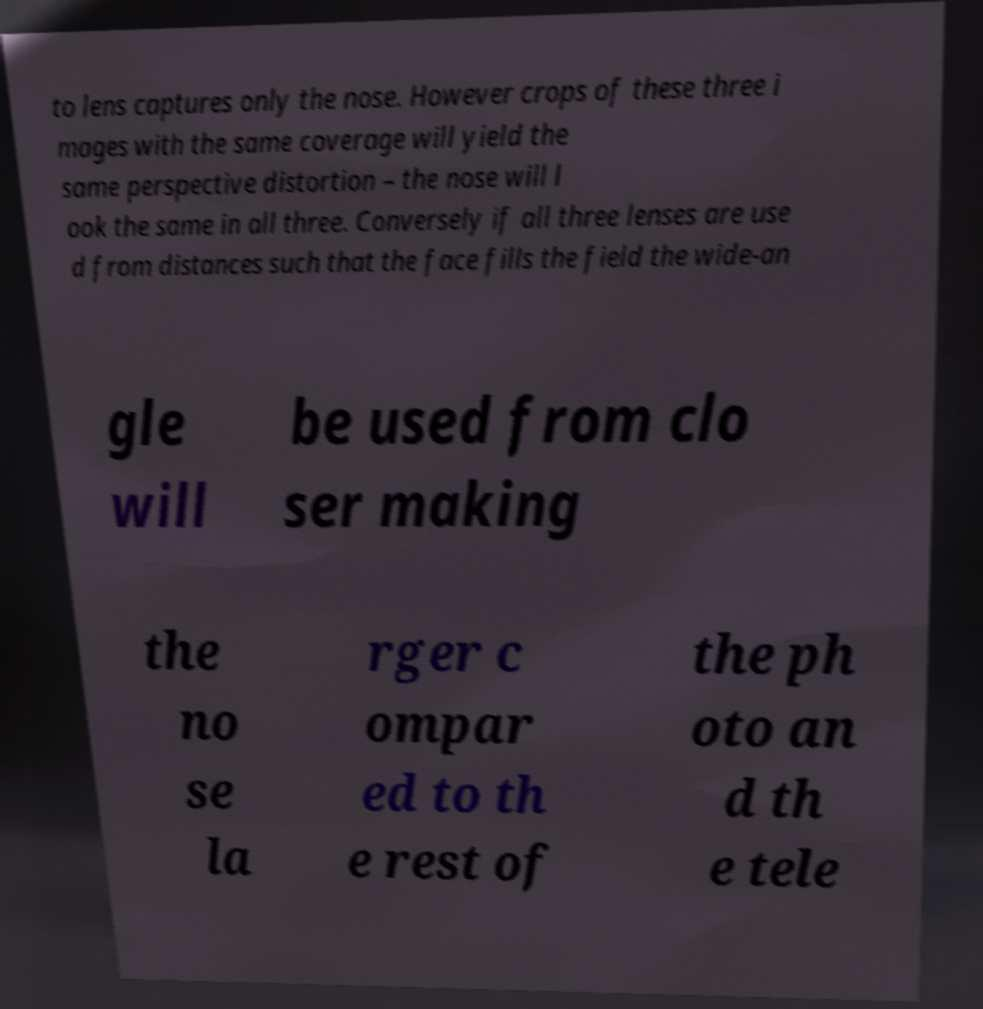Can you read and provide the text displayed in the image?This photo seems to have some interesting text. Can you extract and type it out for me? to lens captures only the nose. However crops of these three i mages with the same coverage will yield the same perspective distortion – the nose will l ook the same in all three. Conversely if all three lenses are use d from distances such that the face fills the field the wide-an gle will be used from clo ser making the no se la rger c ompar ed to th e rest of the ph oto an d th e tele 